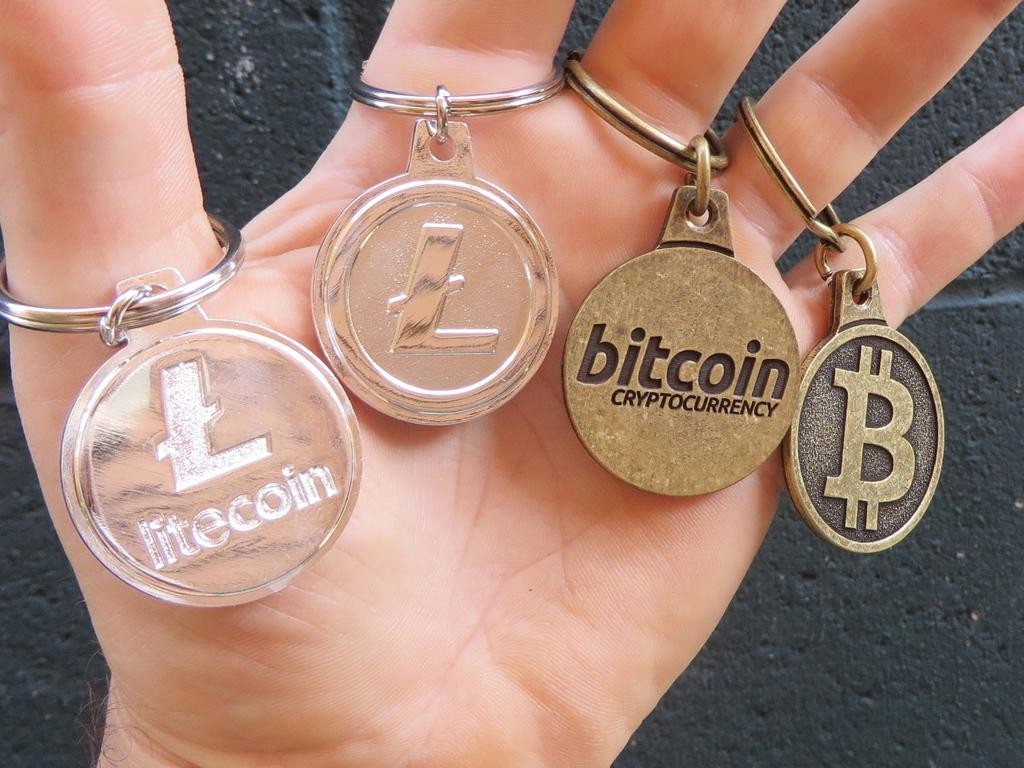<image>
Offer a succinct explanation of the picture presented. A hand with Bitcoin and Litecoin tokens hanging from each finger. 